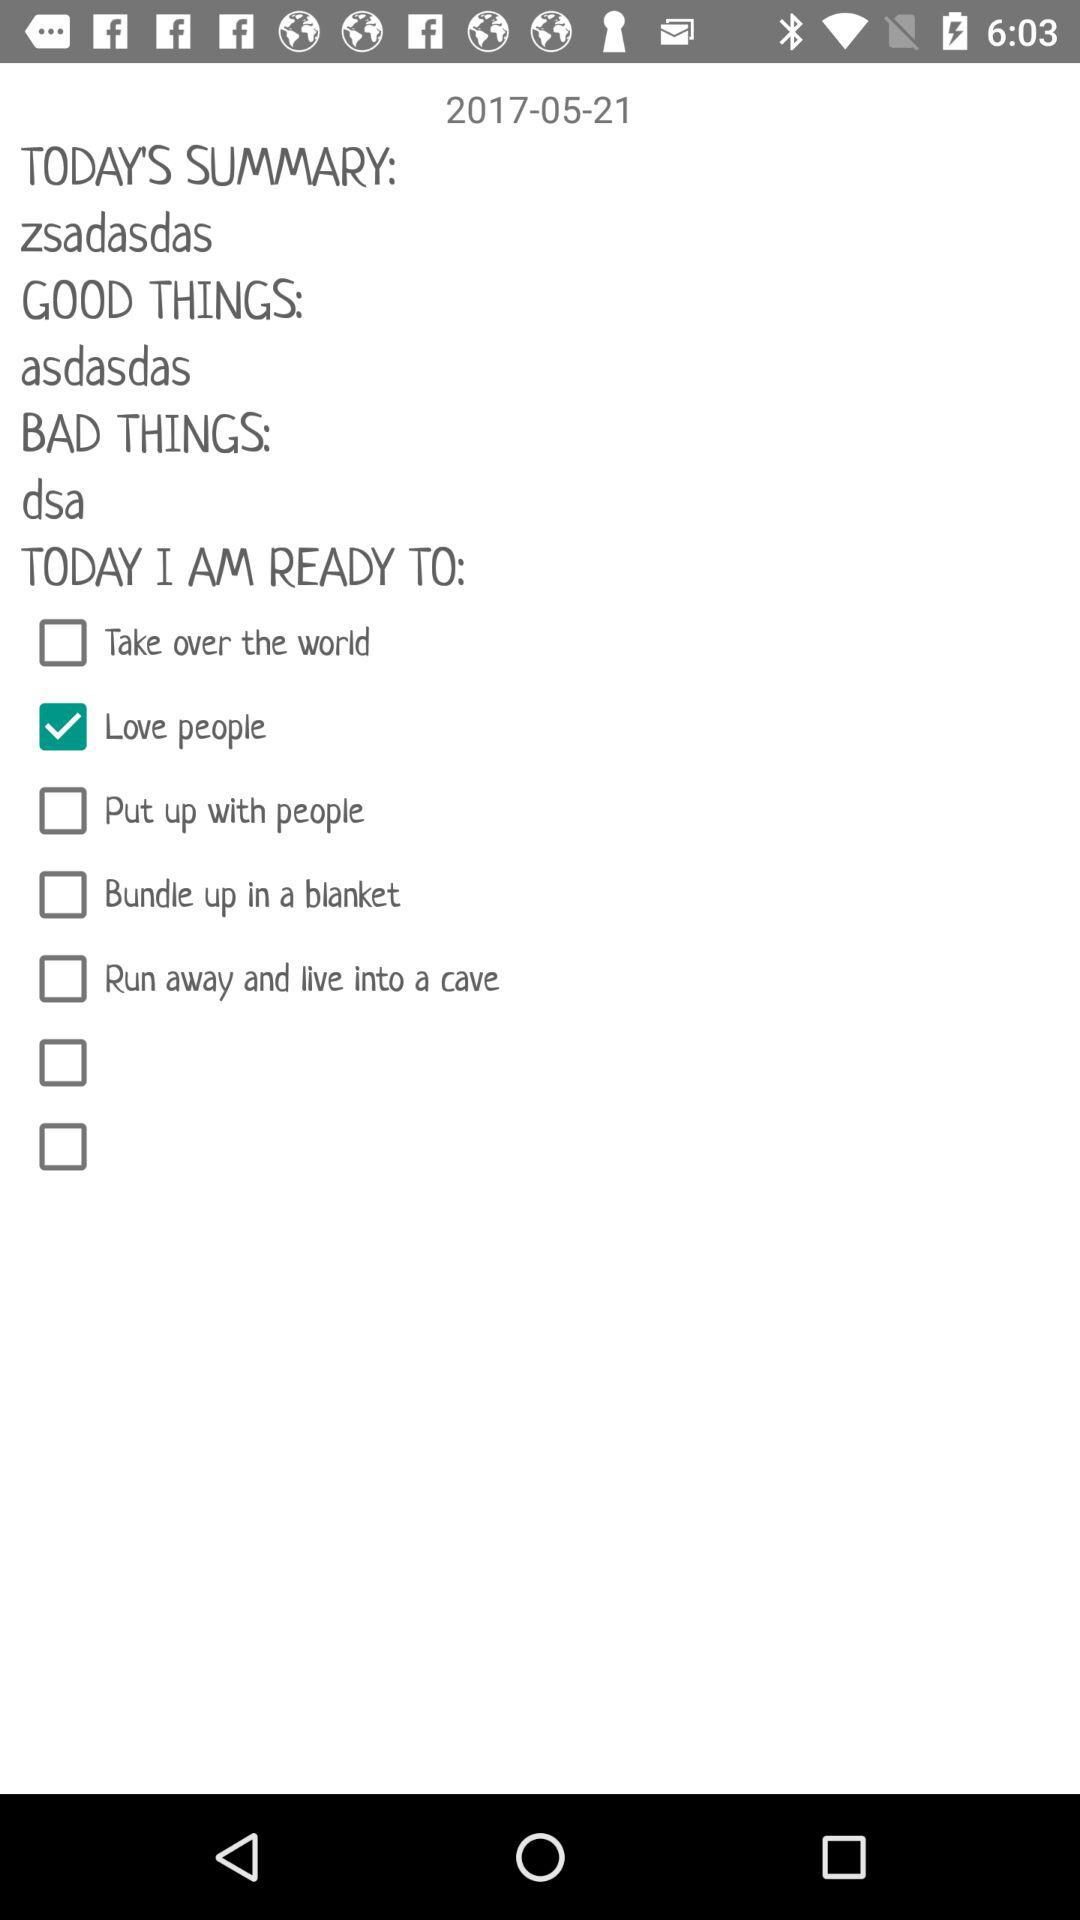Which day of the week falls on June 21, 2017?
When the provided information is insufficient, respond with <no answer>. <no answer> 